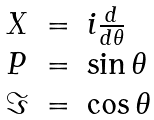<formula> <loc_0><loc_0><loc_500><loc_500>\begin{array} { l l l } X & = & i \frac { d } { d \theta } \\ P & = & \sin \theta \\ \Im & = & \cos \theta \end{array}</formula> 